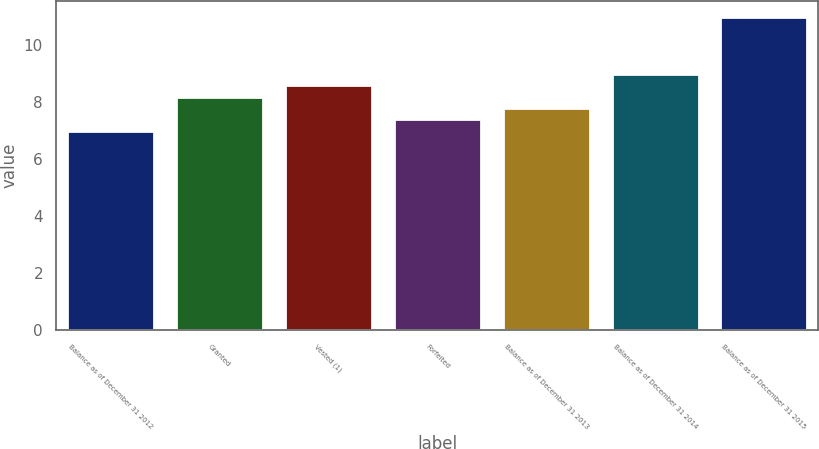Convert chart. <chart><loc_0><loc_0><loc_500><loc_500><bar_chart><fcel>Balance as of December 31 2012<fcel>Granted<fcel>Vested (1)<fcel>Forfeited<fcel>Balance as of December 31 2013<fcel>Balance as of December 31 2014<fcel>Balance as of December 31 2015<nl><fcel>7<fcel>8.2<fcel>8.6<fcel>7.4<fcel>7.8<fcel>9<fcel>11<nl></chart> 